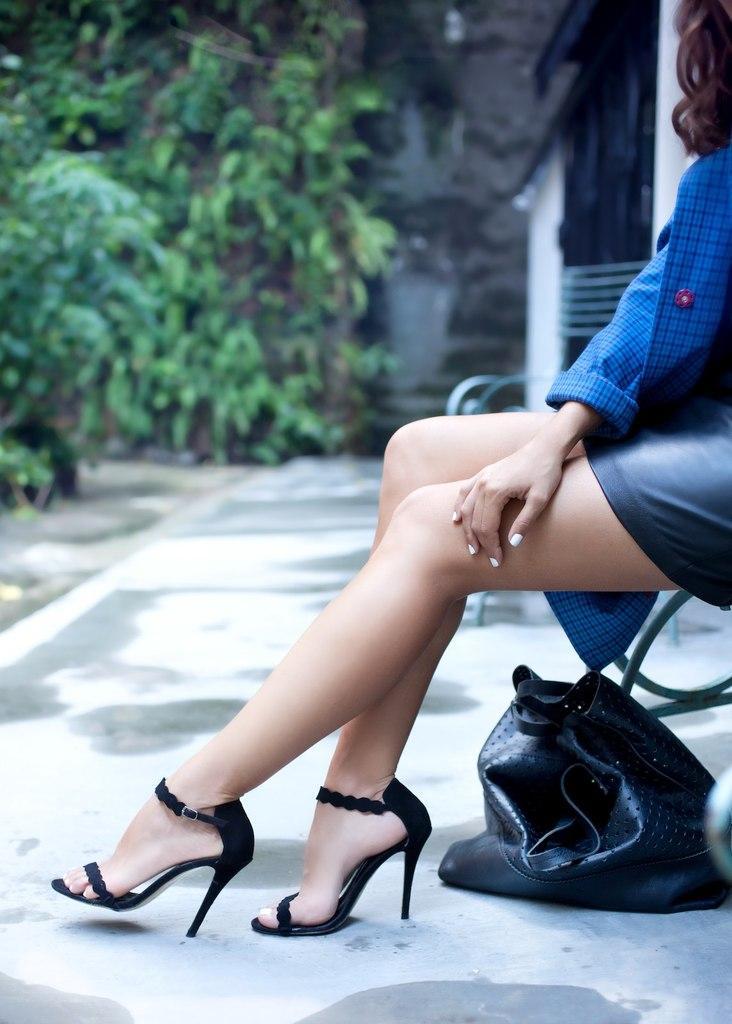Could you give a brief overview of what you see in this image? On the right side of the image there is a lady sitting. She is wearing a blue dress. There is a bag placed on the floor. In the background there are trees. 